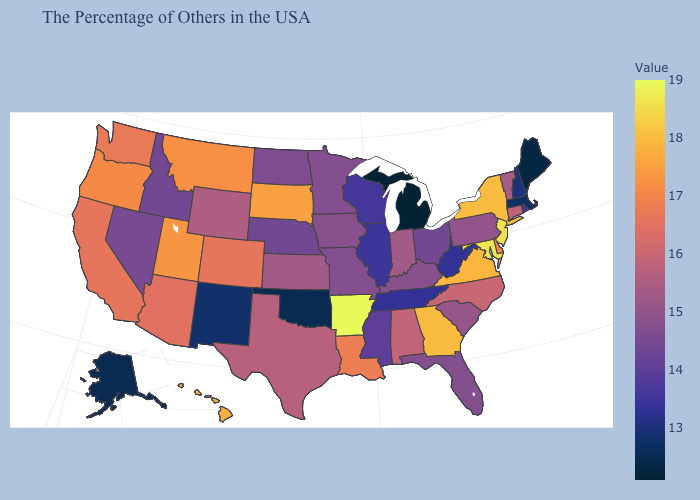Among the states that border Alabama , which have the highest value?
Keep it brief. Georgia. Is the legend a continuous bar?
Short answer required. Yes. Does Michigan have the lowest value in the USA?
Quick response, please. Yes. Does Vermont have a lower value than Wisconsin?
Keep it brief. No. 